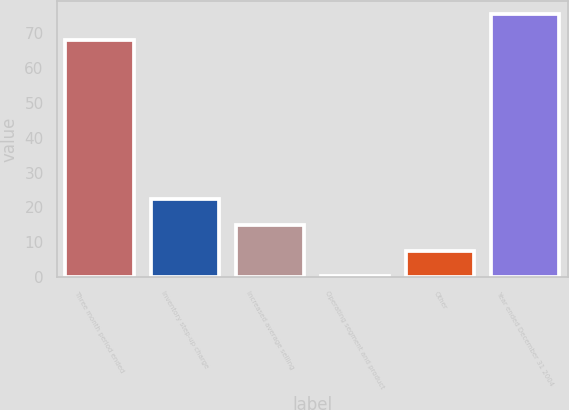<chart> <loc_0><loc_0><loc_500><loc_500><bar_chart><fcel>Three month period ended<fcel>Inventory step-up charge<fcel>Increased average selling<fcel>Operating segment and product<fcel>Other<fcel>Year ended December 31 2004<nl><fcel>68.1<fcel>22.28<fcel>14.92<fcel>0.2<fcel>7.56<fcel>75.46<nl></chart> 